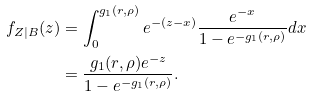<formula> <loc_0><loc_0><loc_500><loc_500>f _ { Z | B } ( z ) & = \int _ { 0 } ^ { g _ { 1 } ( r , \rho ) } e ^ { - ( z - x ) } \frac { e ^ { - x } } { 1 - e ^ { - g _ { 1 } ( r , \rho ) } } d x \\ & = \frac { g _ { 1 } ( r , \rho ) e ^ { - z } } { 1 - e ^ { - g _ { 1 } ( r , \rho ) } } .</formula> 